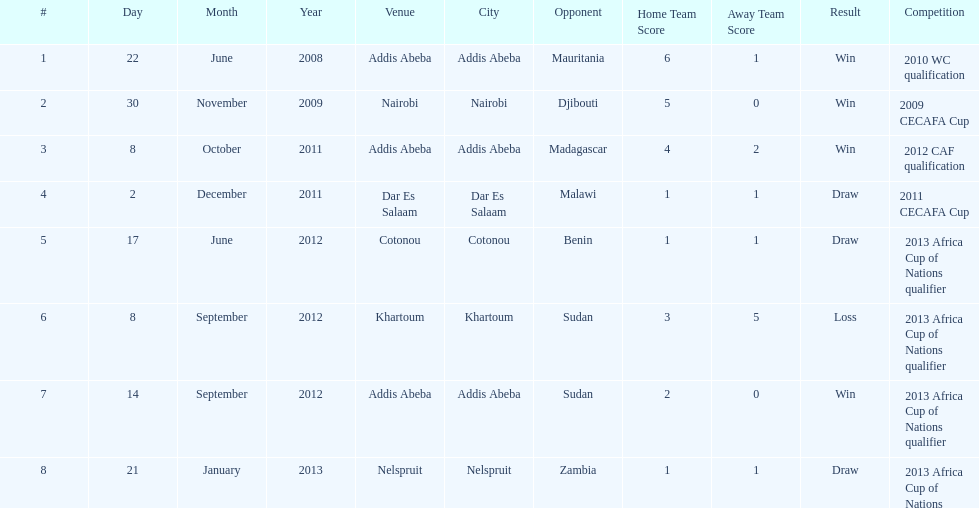For each winning game, what was their score? 6-1, 5-0, 4-2, 2-0. Can you parse all the data within this table? {'header': ['#', 'Day', 'Month', 'Year', 'Venue', 'City', 'Opponent', 'Home Team Score', 'Away Team Score', 'Result', 'Competition'], 'rows': [['1', '22', 'June', '2008', 'Addis Abeba', 'Addis Abeba', 'Mauritania', '6', '1', 'Win', '2010 WC qualification'], ['2', '30', 'November', '2009', 'Nairobi', 'Nairobi', 'Djibouti', '5', '0', 'Win', '2009 CECAFA Cup'], ['3', '8', 'October', '2011', 'Addis Abeba', 'Addis Abeba', 'Madagascar', '4', '2', 'Win', '2012 CAF qualification'], ['4', '2', 'December', '2011', 'Dar Es Salaam', 'Dar Es Salaam', 'Malawi', '1', '1', 'Draw', '2011 CECAFA Cup'], ['5', '17', 'June', '2012', 'Cotonou', 'Cotonou', 'Benin', '1', '1', 'Draw', '2013 Africa Cup of Nations qualifier'], ['6', '8', 'September', '2012', 'Khartoum', 'Khartoum', 'Sudan', '3', '5', 'Loss', '2013 Africa Cup of Nations qualifier'], ['7', '14', 'September', '2012', 'Addis Abeba', 'Addis Abeba', 'Sudan', '2', '0', 'Win', '2013 Africa Cup of Nations qualifier'], ['8', '21', 'January', '2013', 'Nelspruit', 'Nelspruit', 'Zambia', '1', '1', 'Draw', '2013 Africa Cup of Nations']]} 